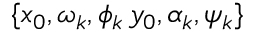Convert formula to latex. <formula><loc_0><loc_0><loc_500><loc_500>\{ x _ { 0 } , \omega _ { k } , \phi _ { k } \, y _ { 0 } , \alpha _ { k } , \psi _ { k } \}</formula> 